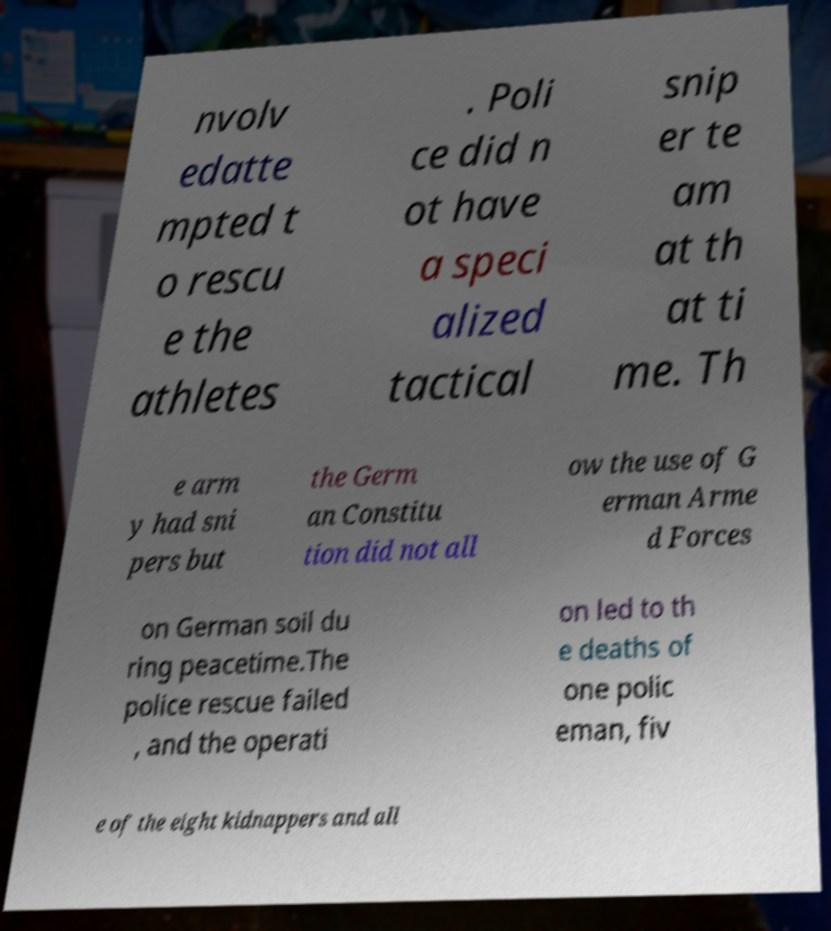Please identify and transcribe the text found in this image. nvolv edatte mpted t o rescu e the athletes . Poli ce did n ot have a speci alized tactical snip er te am at th at ti me. Th e arm y had sni pers but the Germ an Constitu tion did not all ow the use of G erman Arme d Forces on German soil du ring peacetime.The police rescue failed , and the operati on led to th e deaths of one polic eman, fiv e of the eight kidnappers and all 